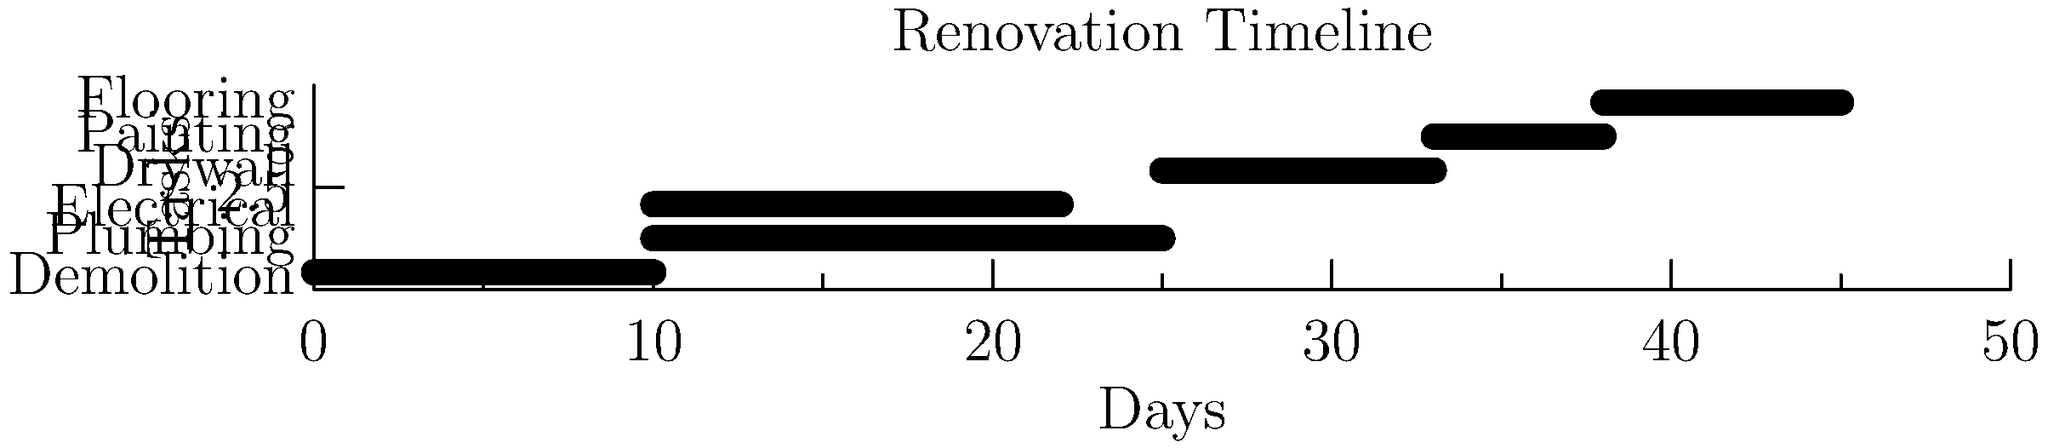Based on the Gantt chart above, which shows the timeline for various home improvement tasks during a renovation project, what is the total duration of the renovation from start to finish? To determine the total duration of the renovation, we need to follow these steps:

1. Identify the start time of the first task:
   The first task (Demolition) starts at day 0.

2. Identify the end time of the last task:
   The last task to finish is Flooring.
   Flooring starts on day 38 and has a duration of 7 days.
   So, it ends on day $38 + 7 = 45$.

3. Calculate the total duration:
   Total duration = End time of last task - Start time of first task
   $45 - 0 = 45$ days

Therefore, the total duration of the renovation project from start to finish is 45 days.
Answer: 45 days 